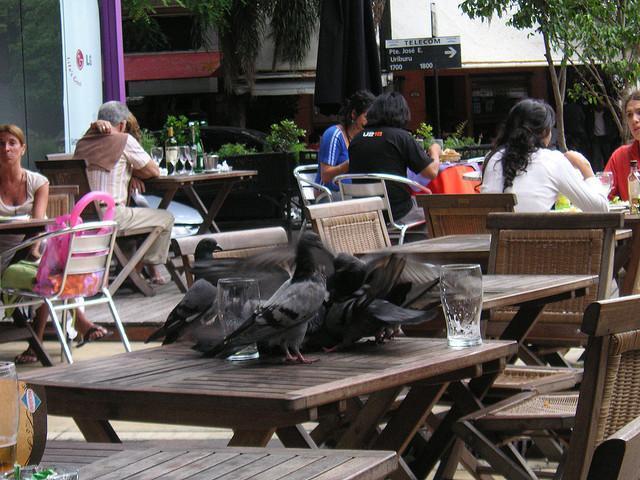How many glasses are on the table?
Give a very brief answer. 2. How many dining tables are in the photo?
Give a very brief answer. 4. How many chairs are there?
Give a very brief answer. 9. How many cups are in the picture?
Give a very brief answer. 2. How many people can be seen?
Give a very brief answer. 5. How many birds can you see?
Give a very brief answer. 3. How many train cars are under the poles?
Give a very brief answer. 0. 